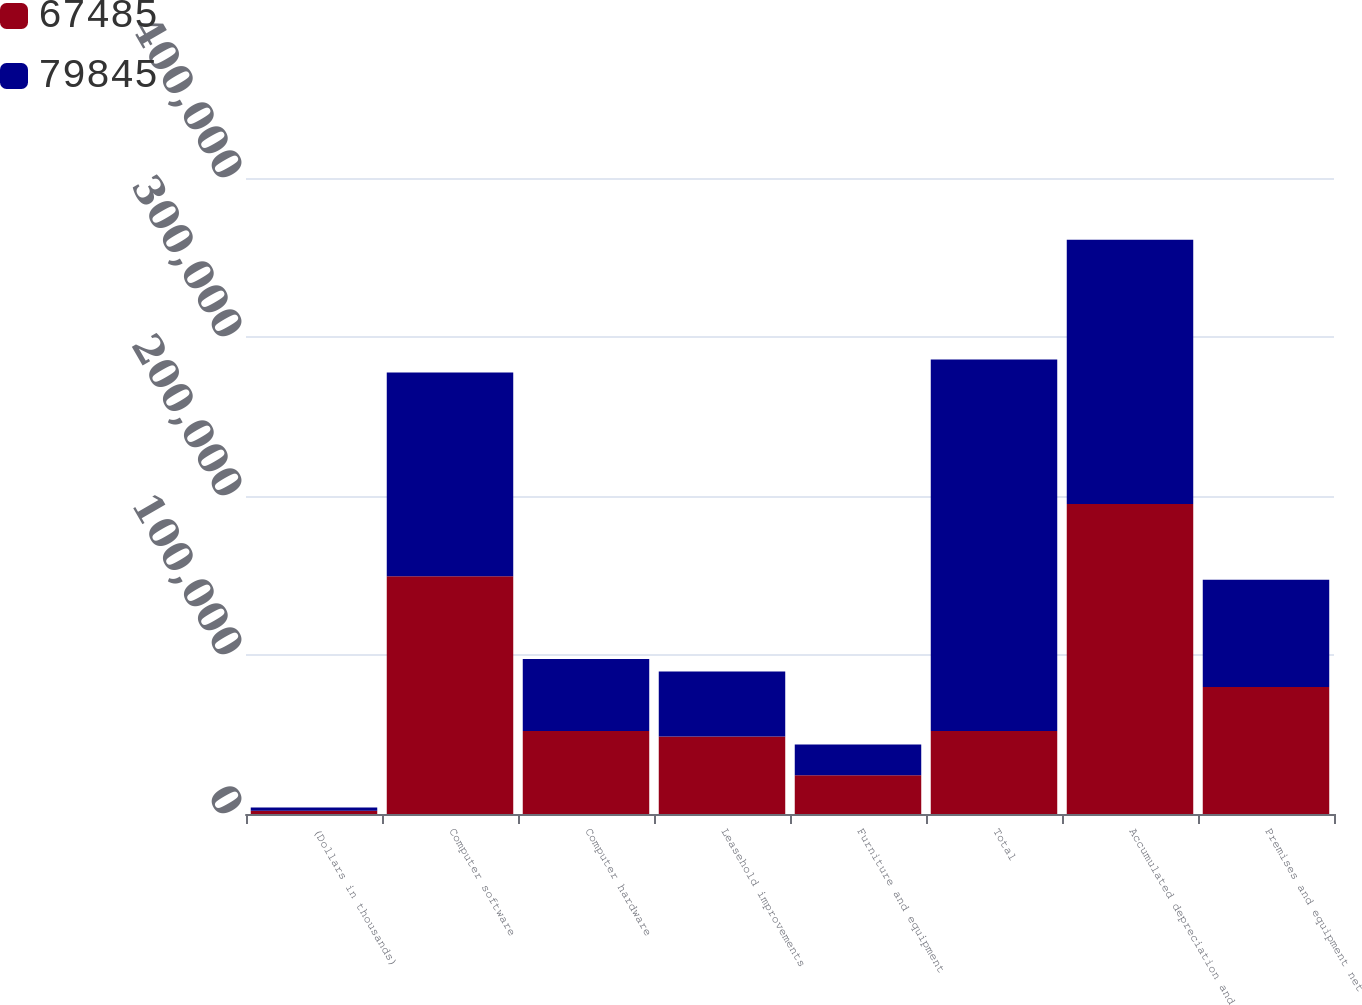Convert chart to OTSL. <chart><loc_0><loc_0><loc_500><loc_500><stacked_bar_chart><ecel><fcel>(Dollars in thousands)<fcel>Computer software<fcel>Computer hardware<fcel>Leasehold improvements<fcel>Furniture and equipment<fcel>Total<fcel>Accumulated depreciation and<fcel>Premises and equipment net<nl><fcel>67485<fcel>2014<fcel>149579<fcel>52203<fcel>48780<fcel>24320<fcel>52203<fcel>195037<fcel>79845<nl><fcel>79845<fcel>2013<fcel>128129<fcel>45241<fcel>40851<fcel>19434<fcel>233655<fcel>166170<fcel>67485<nl></chart> 